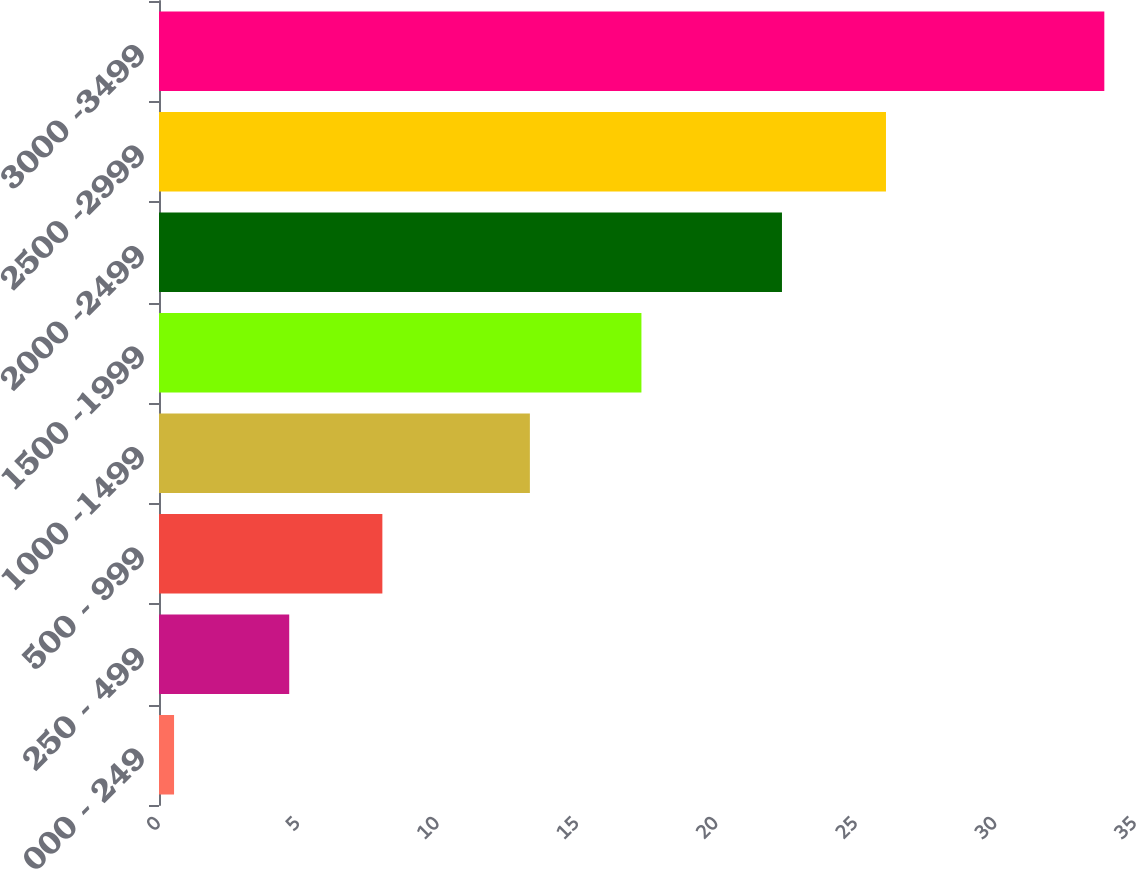Convert chart to OTSL. <chart><loc_0><loc_0><loc_500><loc_500><bar_chart><fcel>000 - 249<fcel>250 - 499<fcel>500 - 999<fcel>1000 -1499<fcel>1500 -1999<fcel>2000 -2499<fcel>2500 -2999<fcel>3000 -3499<nl><fcel>0.54<fcel>4.67<fcel>8.01<fcel>13.3<fcel>17.3<fcel>22.34<fcel>26.07<fcel>33.9<nl></chart> 